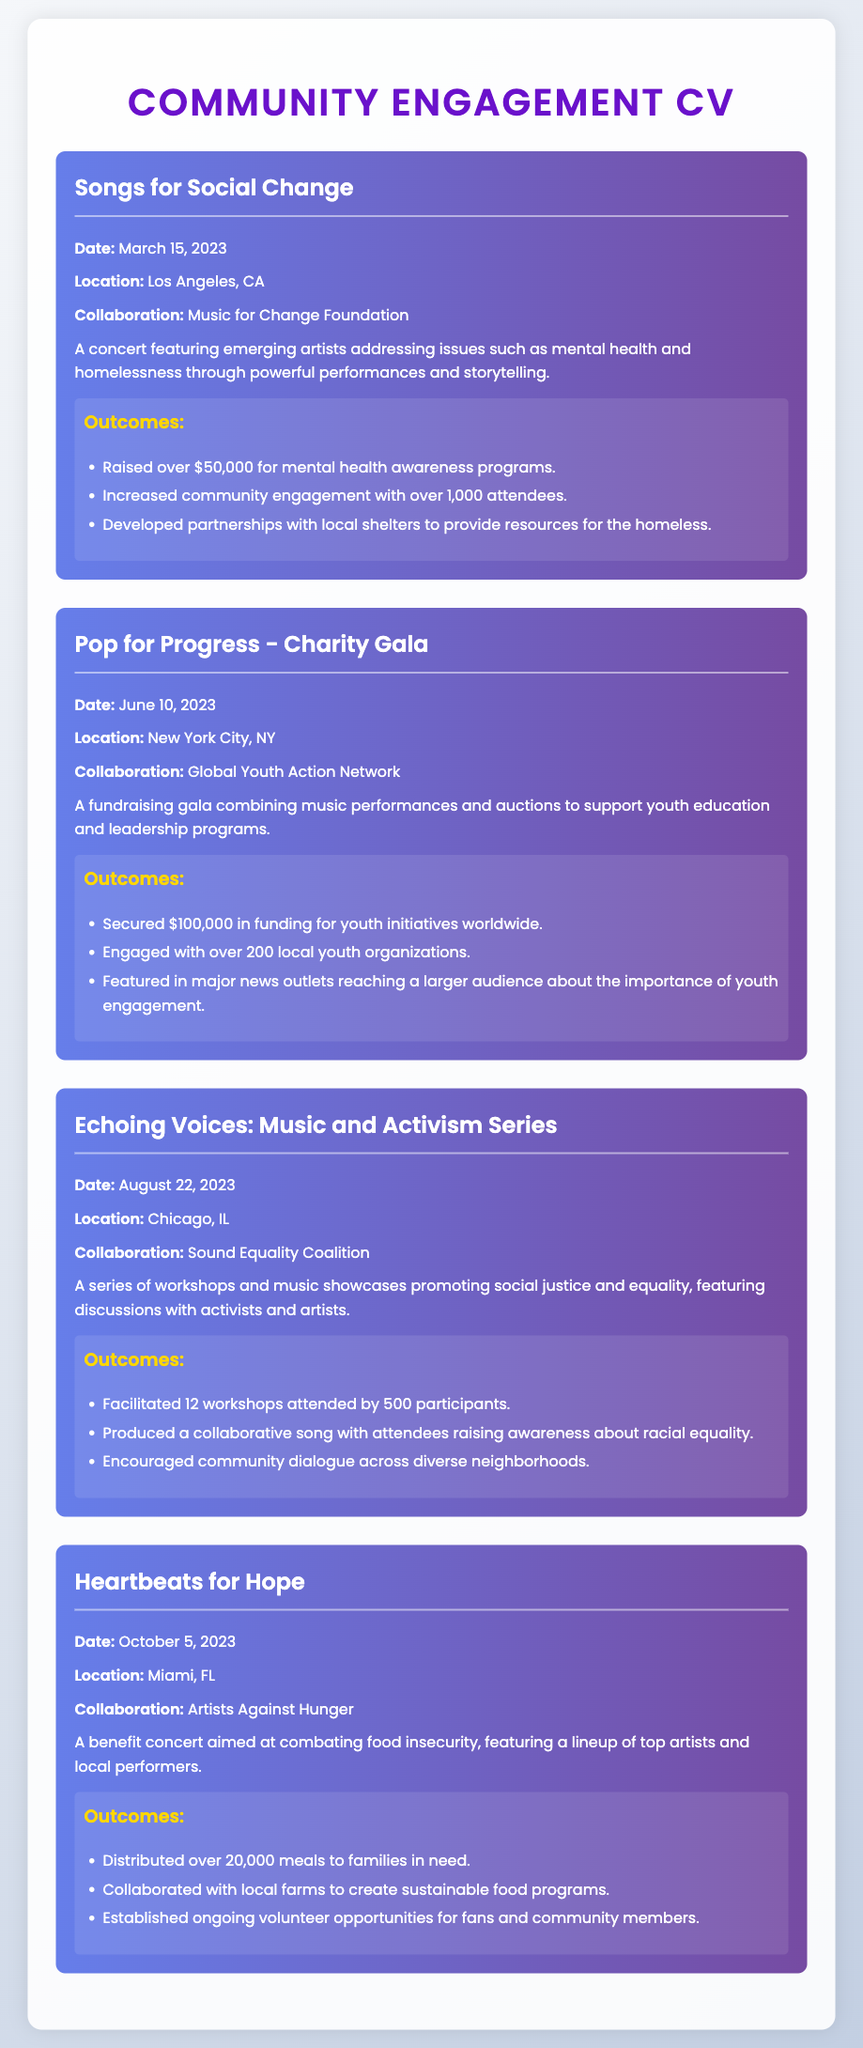what is the date of the "Songs for Social Change" event? The date for the "Songs for Social Change" event is explicitly mentioned in the document.
Answer: March 15, 2023 who collaborated with the "Heartbeats for Hope" concert? The document specifies the collaboration involved in the "Heartbeats for Hope" concert.
Answer: Artists Against Hunger how much money was raised during the "Pop for Progress - Charity Gala"? The document provides the amount secured during the "Pop for Progress - Charity Gala".
Answer: $100,000 how many workshops were facilitated in the "Echoing Voices: Music and Activism Series"? The document mentions the total number of workshops conducted as part of the series.
Answer: 12 what was the outcome of the "Songs for Social Change" event regarding attendance? The document describes the level of engagement and attendance achieved at the event.
Answer: over 1,000 attendees which city hosted the "Pop for Progress - Charity Gala"? The document clearly states the location of the gala event.
Answer: New York City, NY how many meals were distributed during the "Heartbeats for Hope" concert? The document indicates the total number of meals given to families in need during the concert.
Answer: over 20,000 meals what social issue was addressed by the "Echoing Voices: Music and Activism Series"? The document outlines the main focus of the workshops and music showcases within the initiative.
Answer: social justice what was the main purpose of the "Pop for Progress - Charity Gala"? The document describes the goal behind organizing the gala event.
Answer: support youth education and leadership programs 